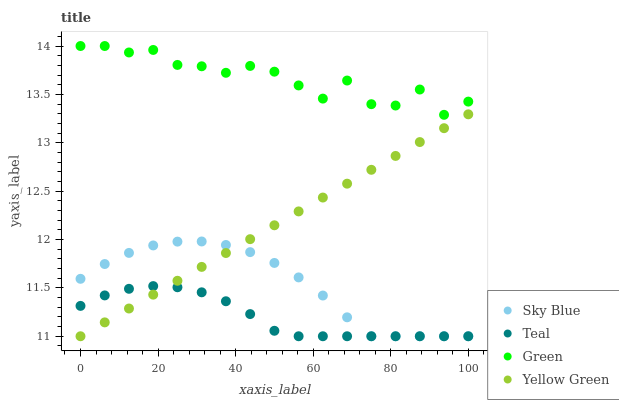Does Teal have the minimum area under the curve?
Answer yes or no. Yes. Does Green have the maximum area under the curve?
Answer yes or no. Yes. Does Yellow Green have the minimum area under the curve?
Answer yes or no. No. Does Yellow Green have the maximum area under the curve?
Answer yes or no. No. Is Yellow Green the smoothest?
Answer yes or no. Yes. Is Green the roughest?
Answer yes or no. Yes. Is Green the smoothest?
Answer yes or no. No. Is Yellow Green the roughest?
Answer yes or no. No. Does Sky Blue have the lowest value?
Answer yes or no. Yes. Does Green have the lowest value?
Answer yes or no. No. Does Green have the highest value?
Answer yes or no. Yes. Does Yellow Green have the highest value?
Answer yes or no. No. Is Sky Blue less than Green?
Answer yes or no. Yes. Is Green greater than Sky Blue?
Answer yes or no. Yes. Does Sky Blue intersect Teal?
Answer yes or no. Yes. Is Sky Blue less than Teal?
Answer yes or no. No. Is Sky Blue greater than Teal?
Answer yes or no. No. Does Sky Blue intersect Green?
Answer yes or no. No. 